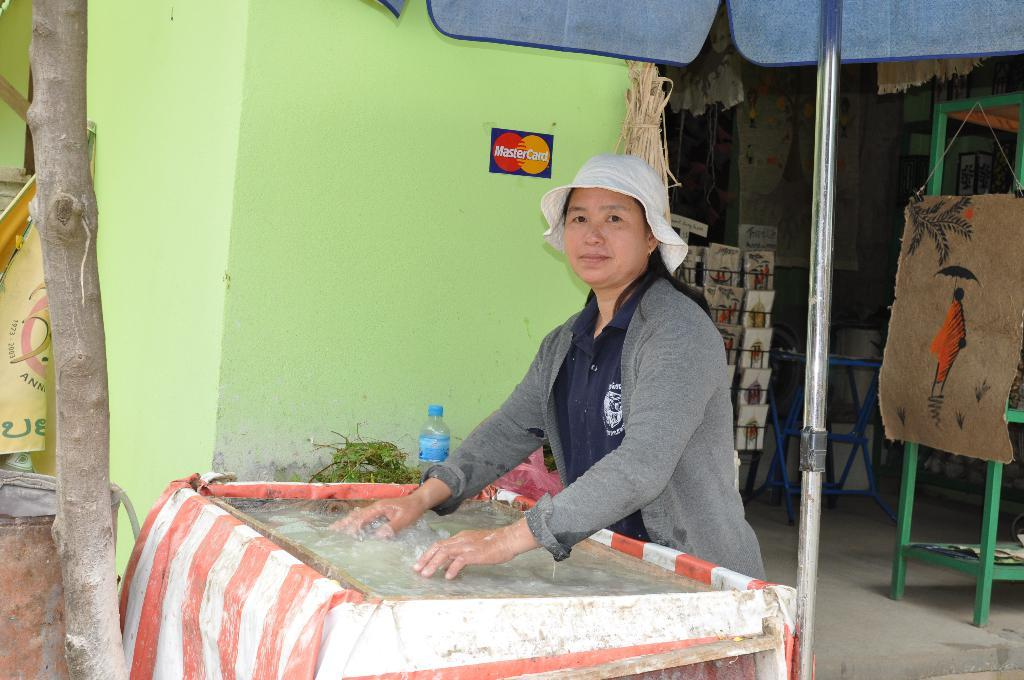What is the main subject of the image? There is a woman standing in the image. Can you describe the woman's attire? The woman is wearing clothes and a cap. What other objects can be seen in the image? There is a water bottle, a painting, a pole, and a tree trunk in the image. What type of zinc is present in the image? There is no zinc present in the image. How many plants can be seen growing on the side of the tree trunk? There are no plants visible on the tree trunk in the image. 